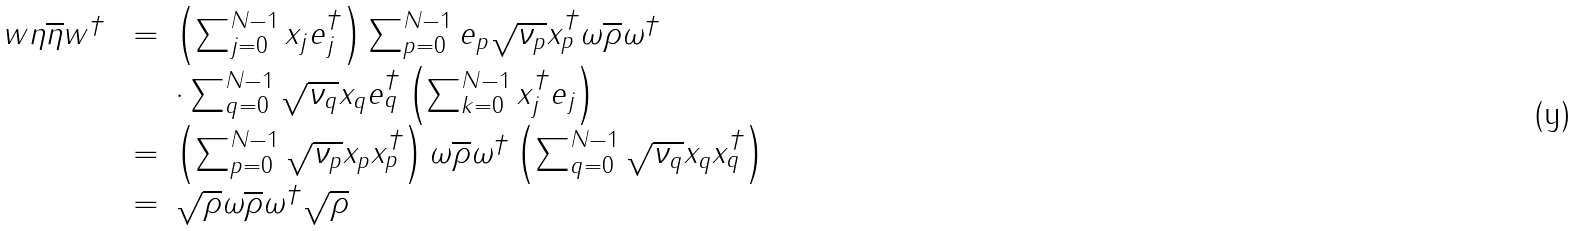<formula> <loc_0><loc_0><loc_500><loc_500>\begin{array} { l l l } w \eta \overline { \eta } w ^ { \dagger } \ & = & \left ( \sum _ { j = 0 } ^ { N - 1 } x _ { j } e _ { j } ^ { \dagger } \right ) \sum _ { p = 0 } ^ { N - 1 } e _ { p } \sqrt { \nu _ { p } } x _ { p } ^ { \dagger } \omega \overline { \rho } \omega ^ { \dagger } \\ & & \cdot \sum _ { q = 0 } ^ { N - 1 } \sqrt { \nu _ { q } } x _ { q } e _ { q } ^ { \dagger } \left ( \sum _ { k = 0 } ^ { N - 1 } x _ { j } ^ { \dagger } e _ { j } \right ) \\ & = & \left ( \sum _ { p = 0 } ^ { N - 1 } \sqrt { \nu _ { p } } x _ { p } x _ { p } ^ { \dagger } \right ) \omega \overline { \rho } \omega ^ { \dagger } \left ( \sum _ { q = 0 } ^ { N - 1 } \sqrt { \nu _ { q } } x _ { q } x _ { q } ^ { \dagger } \right ) \\ & = & \sqrt { \rho } \omega \overline { \rho } \omega ^ { \dagger } \sqrt { \rho } \\ \end{array}</formula> 